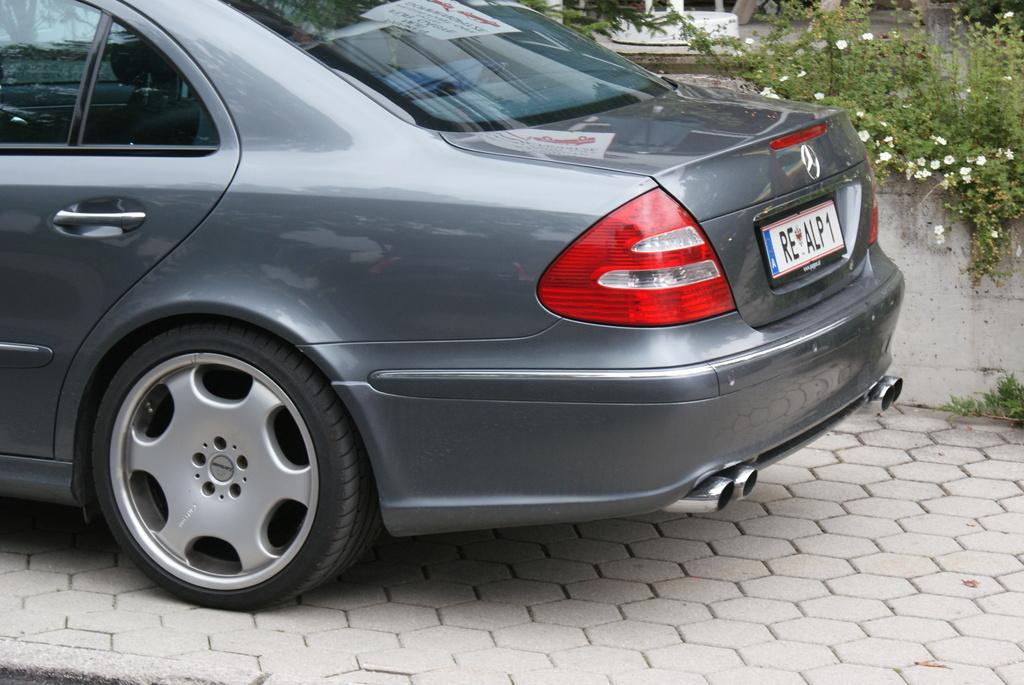What is the main subject of the image? The main subject of the image is a car. Can you describe any specific features of the car? Yes, the car has a number plate. What can be seen on the right side of the image? There is a wall on the right side of the image. What type of vegetation is near the wall? There are flowers on plants near the wall. How is the ground depicted in the image? The ground has a floor with bricks. Can you tell me how the self is adjusting the machine in the image? There is no self or machine present in the image; it features a car, a wall, flowers, and a brick floor. 